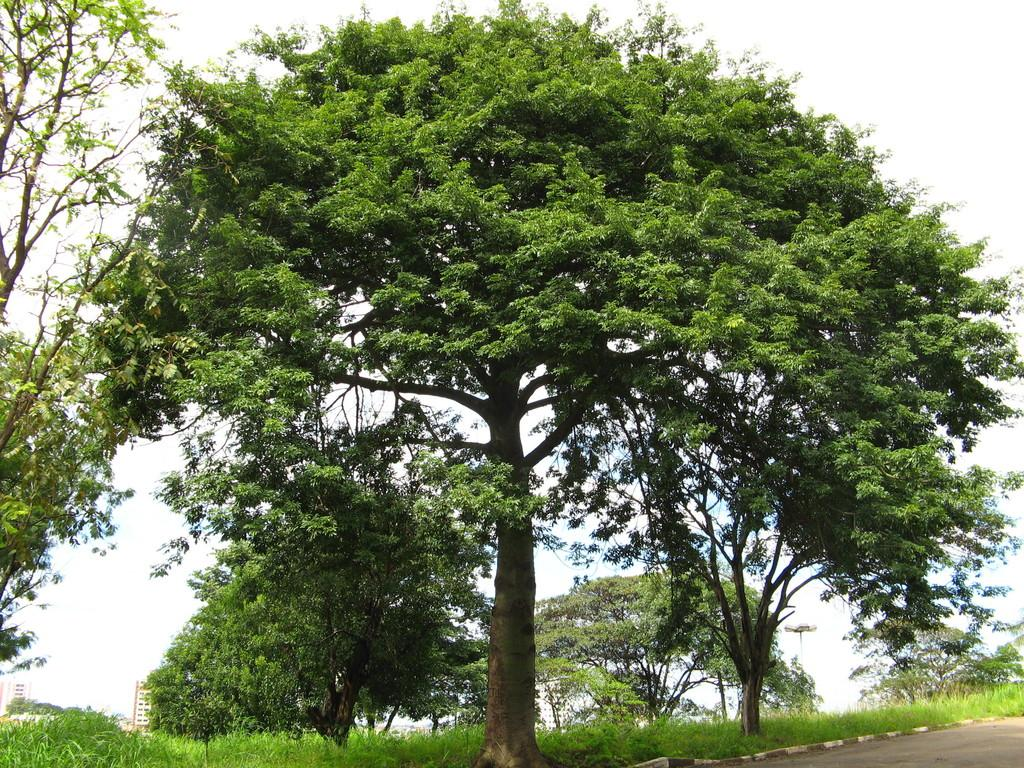What type of vegetation can be seen in the image? There are trees in the image. What is on the ground in the image? There is grass on the ground in the image. Where is the road located in the image? The road is in the bottom right corner of the image. What structures can be seen in the distance in the image? There are buildings in the background of the image. What is visible at the top of the image? The sky is visible at the top of the image. Can you tell me how many cameras are visible on the floor in the image? There are no cameras visible on the floor in the image. Is there a seashore present in the image? There is: There is no seashore present in the image. 